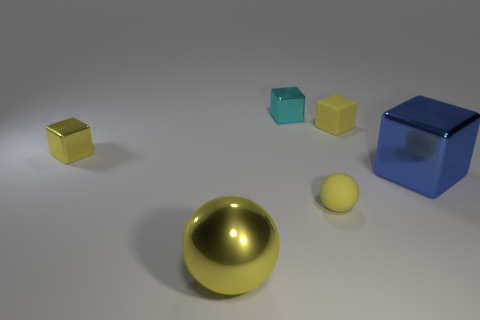How many matte objects are either large blue blocks or large yellow objects?
Offer a very short reply. 0. There is a cyan metal thing; what shape is it?
Provide a short and direct response. Cube. How many small yellow blocks are made of the same material as the tiny ball?
Your answer should be very brief. 1. There is a large block that is the same material as the small cyan cube; what is its color?
Provide a succinct answer. Blue. Do the rubber thing right of the matte ball and the big sphere have the same size?
Your response must be concise. No. There is another thing that is the same shape as the big yellow shiny object; what color is it?
Your answer should be compact. Yellow. The tiny object left of the cyan thing behind the small rubber object in front of the yellow matte cube is what shape?
Your answer should be very brief. Cube. Does the large yellow object have the same shape as the large blue thing?
Your answer should be very brief. No. What is the shape of the yellow shiny object on the right side of the yellow metal thing behind the big yellow metallic sphere?
Provide a short and direct response. Sphere. Are there any big balls?
Your answer should be very brief. Yes. 